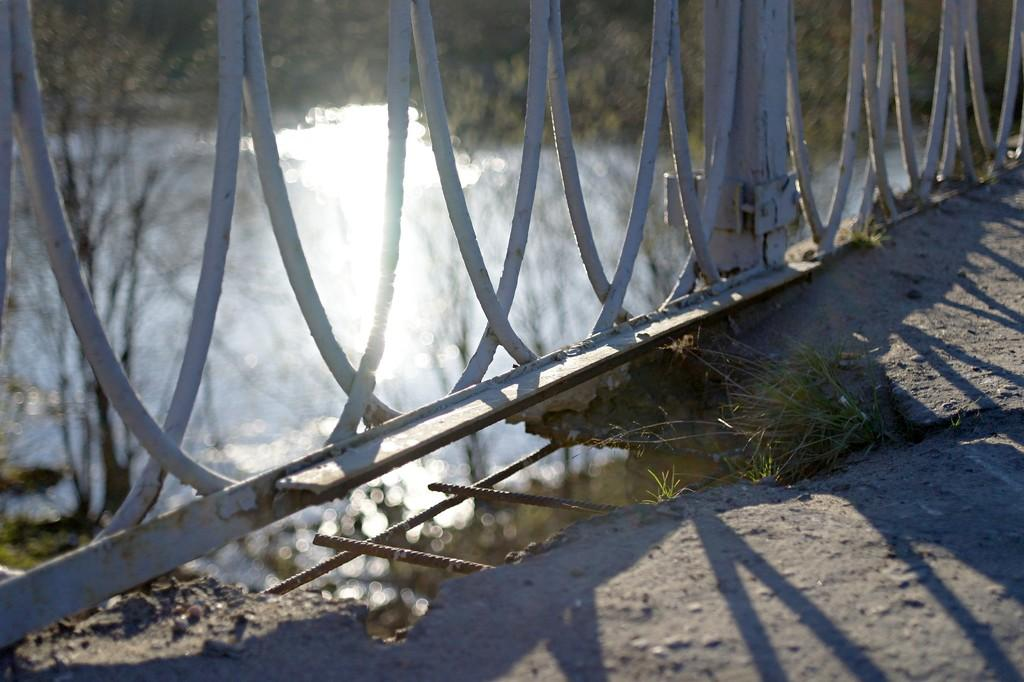What type of ground surface is visible in the image? There is grass on the ground in the image. What structure can be seen in the image? There is a railing in the image. What natural element is visible in the image? There is water visible in the image. What type of vegetation is present in the image? There are many trees in the image. What type of wool can be seen in the image? There is no wool present in the image. How many clouds are visible in the image? There is no mention of clouds in the image; it features grass, a railing, water, and trees. 